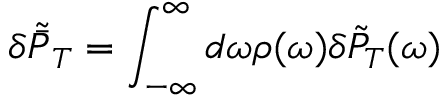<formula> <loc_0><loc_0><loc_500><loc_500>\delta \tilde { \bar { P } } _ { T } = \int _ { - \infty } ^ { \infty } d \omega \rho ( \omega ) \delta \tilde { P } _ { T } ( \omega )</formula> 